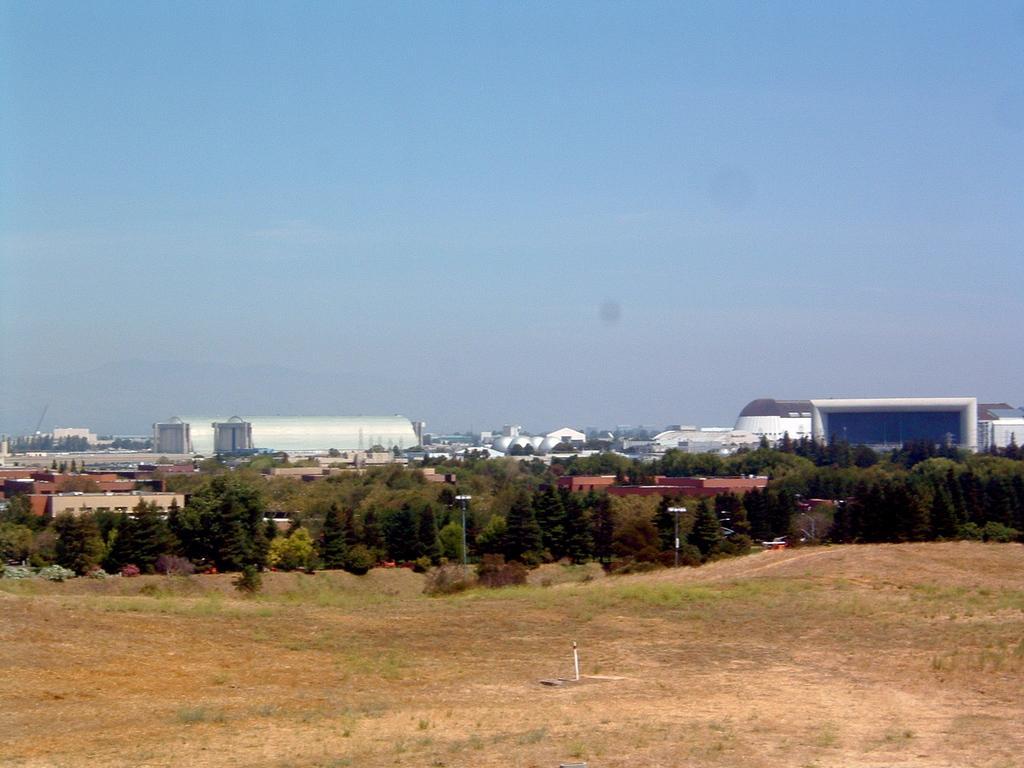Please provide a concise description of this image. In this image we can see trees, street poles, street lights, ground, bushes, factory equipment and sky with clouds. 